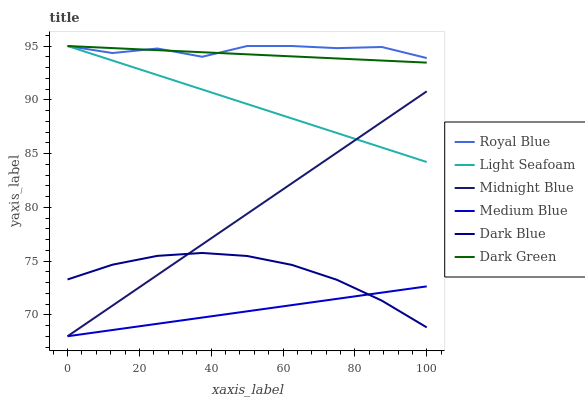Does Medium Blue have the minimum area under the curve?
Answer yes or no. Yes. Does Royal Blue have the maximum area under the curve?
Answer yes or no. Yes. Does Dark Blue have the minimum area under the curve?
Answer yes or no. No. Does Dark Blue have the maximum area under the curve?
Answer yes or no. No. Is Dark Green the smoothest?
Answer yes or no. Yes. Is Royal Blue the roughest?
Answer yes or no. Yes. Is Dark Blue the smoothest?
Answer yes or no. No. Is Dark Blue the roughest?
Answer yes or no. No. Does Dark Blue have the lowest value?
Answer yes or no. No. Does Dark Blue have the highest value?
Answer yes or no. No. Is Dark Blue less than Light Seafoam?
Answer yes or no. Yes. Is Dark Green greater than Dark Blue?
Answer yes or no. Yes. Does Dark Blue intersect Light Seafoam?
Answer yes or no. No. 